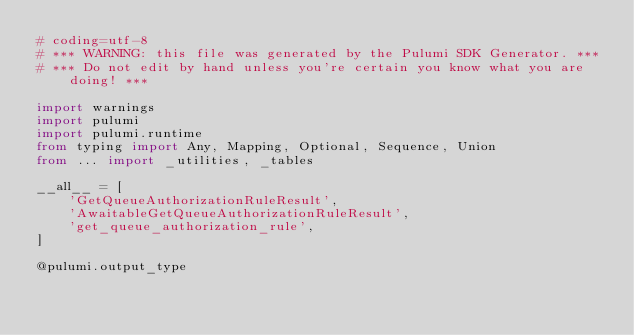Convert code to text. <code><loc_0><loc_0><loc_500><loc_500><_Python_># coding=utf-8
# *** WARNING: this file was generated by the Pulumi SDK Generator. ***
# *** Do not edit by hand unless you're certain you know what you are doing! ***

import warnings
import pulumi
import pulumi.runtime
from typing import Any, Mapping, Optional, Sequence, Union
from ... import _utilities, _tables

__all__ = [
    'GetQueueAuthorizationRuleResult',
    'AwaitableGetQueueAuthorizationRuleResult',
    'get_queue_authorization_rule',
]

@pulumi.output_type</code> 